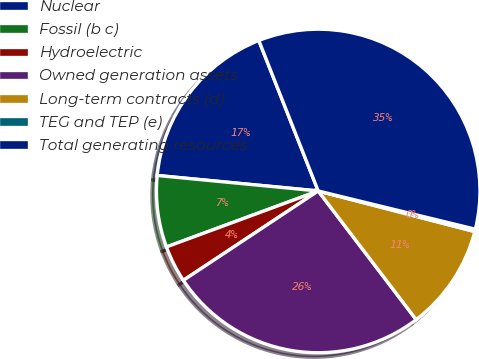Convert chart. <chart><loc_0><loc_0><loc_500><loc_500><pie_chart><fcel>Nuclear<fcel>Fossil (b c)<fcel>Hydroelectric<fcel>Owned generation assets<fcel>Long-term contracts (d)<fcel>TEG and TEP (e)<fcel>Total generating resources<nl><fcel>17.49%<fcel>7.15%<fcel>3.69%<fcel>26.04%<fcel>10.6%<fcel>0.24%<fcel>34.78%<nl></chart> 